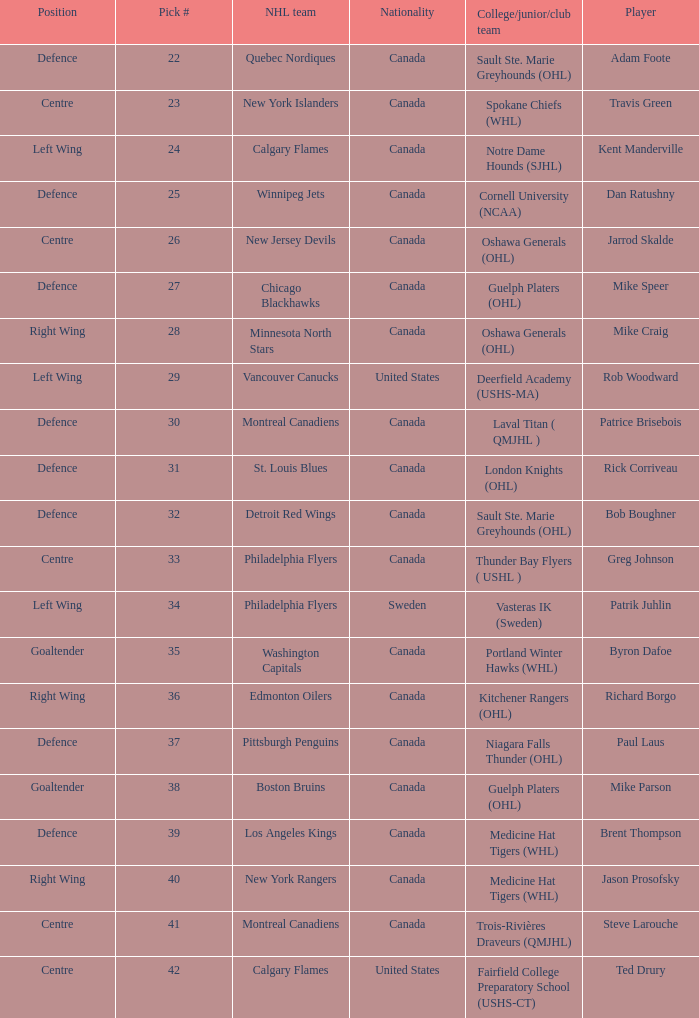What player came from Cornell University (NCAA)? Dan Ratushny. 